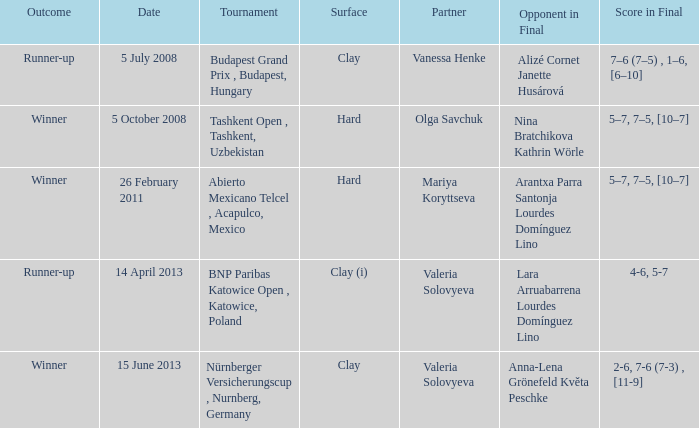What is the result for alizé cornet and janette husárová facing each other in the final? Runner-up. 